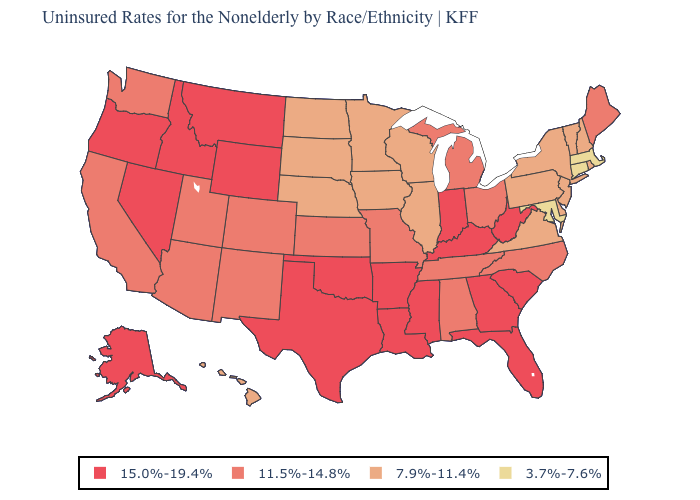What is the highest value in states that border Kansas?
Give a very brief answer. 15.0%-19.4%. What is the highest value in the USA?
Be succinct. 15.0%-19.4%. What is the value of Illinois?
Be succinct. 7.9%-11.4%. What is the value of Arizona?
Write a very short answer. 11.5%-14.8%. Does Oklahoma have a higher value than Louisiana?
Answer briefly. No. What is the value of North Dakota?
Be succinct. 7.9%-11.4%. What is the lowest value in states that border Ohio?
Answer briefly. 7.9%-11.4%. Among the states that border Colorado , which have the highest value?
Write a very short answer. Oklahoma, Wyoming. How many symbols are there in the legend?
Concise answer only. 4. Name the states that have a value in the range 7.9%-11.4%?
Write a very short answer. Delaware, Hawaii, Illinois, Iowa, Minnesota, Nebraska, New Hampshire, New Jersey, New York, North Dakota, Pennsylvania, Rhode Island, South Dakota, Vermont, Virginia, Wisconsin. Does Colorado have the highest value in the West?
Give a very brief answer. No. Name the states that have a value in the range 3.7%-7.6%?
Give a very brief answer. Connecticut, Maryland, Massachusetts. What is the value of New Jersey?
Short answer required. 7.9%-11.4%. Which states have the lowest value in the USA?
Keep it brief. Connecticut, Maryland, Massachusetts. Which states have the lowest value in the West?
Be succinct. Hawaii. 